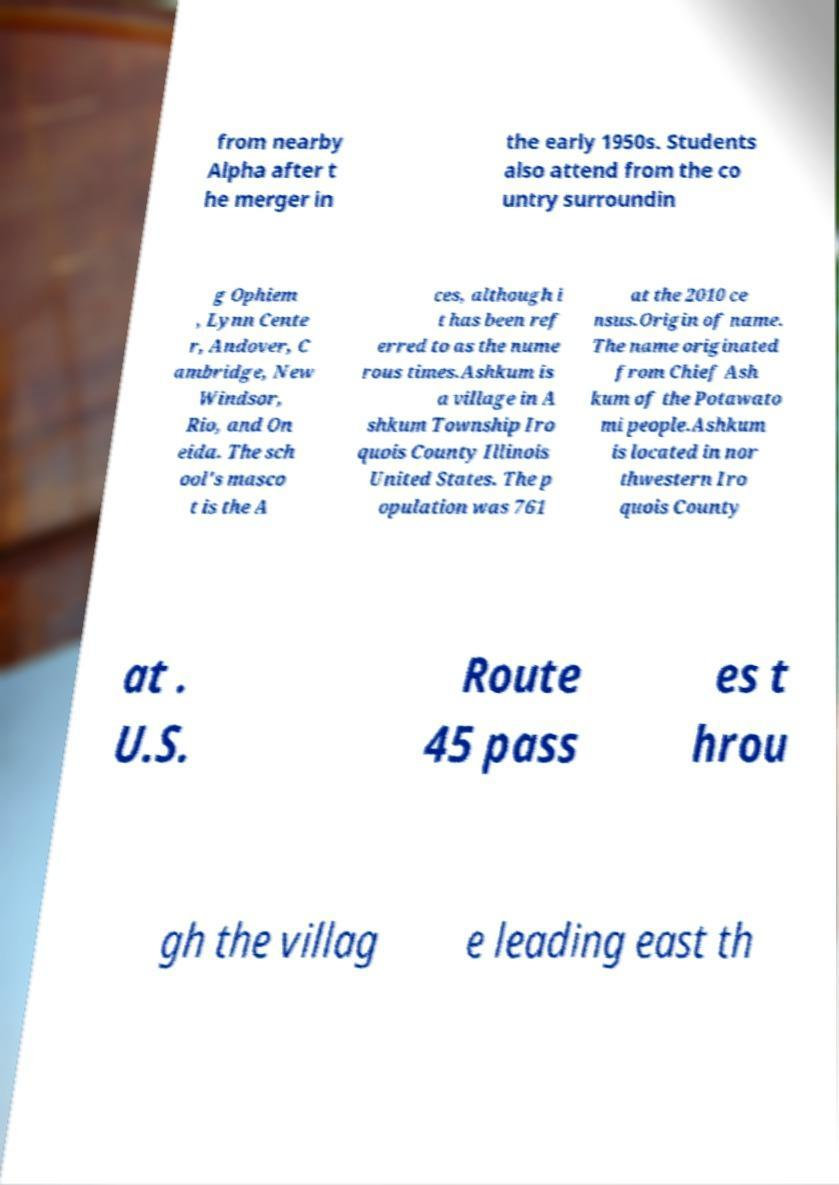Can you accurately transcribe the text from the provided image for me? from nearby Alpha after t he merger in the early 1950s. Students also attend from the co untry surroundin g Ophiem , Lynn Cente r, Andover, C ambridge, New Windsor, Rio, and On eida. The sch ool's masco t is the A ces, although i t has been ref erred to as the nume rous times.Ashkum is a village in A shkum Township Iro quois County Illinois United States. The p opulation was 761 at the 2010 ce nsus.Origin of name. The name originated from Chief Ash kum of the Potawato mi people.Ashkum is located in nor thwestern Iro quois County at . U.S. Route 45 pass es t hrou gh the villag e leading east th 